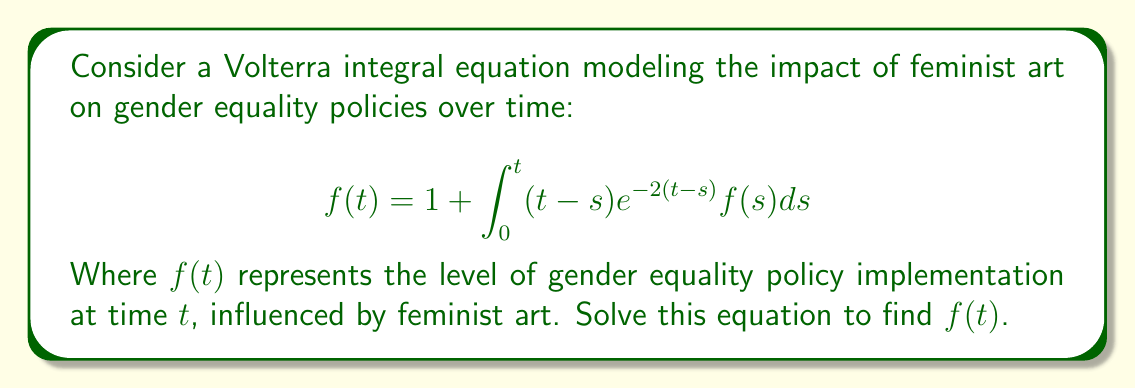Solve this math problem. 1) First, we recognize this as a Volterra integral equation of the second kind.

2) To solve this, we'll use the Laplace transform method. Let $F(s)$ be the Laplace transform of $f(t)$.

3) Take the Laplace transform of both sides:
   $$\mathcal{L}\{f(t)\} = \mathcal{L}\{1\} + \mathcal{L}\{\int_0^t (t-s)e^{-2(t-s)}f(s)ds\}$$

4) Using Laplace transform properties:
   $$F(s) = \frac{1}{s} + \mathcal{L}\{(t-s)e^{-2(t-s)}\} \cdot F(s)$$

5) The Laplace transform of $(t-s)e^{-2(t-s)}$ is $\frac{1}{(s+2)^2}$

6) Substituting:
   $$F(s) = \frac{1}{s} + \frac{1}{(s+2)^2} \cdot F(s)$$

7) Rearranging:
   $$F(s) - \frac{1}{(s+2)^2} \cdot F(s) = \frac{1}{s}$$
   $$F(s) \cdot (1 - \frac{1}{(s+2)^2}) = \frac{1}{s}$$

8) Simplifying:
   $$F(s) \cdot \frac{(s+2)^2-1}{(s+2)^2} = \frac{1}{s}$$
   $$F(s) = \frac{(s+2)^2}{s((s+2)^2-1)}$$

9) Decomposing into partial fractions:
   $$F(s) = \frac{1}{s} + \frac{2}{s+1} + \frac{1}{s+3}$$

10) Taking the inverse Laplace transform:
    $$f(t) = 1 + 2e^{-t} + e^{-3t}$$

This is the solution to the Volterra integral equation.
Answer: $f(t) = 1 + 2e^{-t} + e^{-3t}$ 